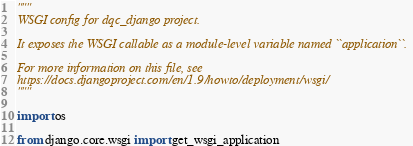Convert code to text. <code><loc_0><loc_0><loc_500><loc_500><_Python_>"""
WSGI config for dqc_django project.

It exposes the WSGI callable as a module-level variable named ``application``.

For more information on this file, see
https://docs.djangoproject.com/en/1.9/howto/deployment/wsgi/
"""

import os

from django.core.wsgi import get_wsgi_application
</code> 